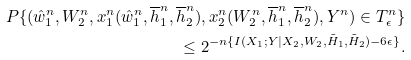<formula> <loc_0><loc_0><loc_500><loc_500>P \{ ( \hat { w } _ { 1 } ^ { n } , W _ { 2 } ^ { n } , x _ { 1 } ^ { n } ( \hat { w } _ { 1 } ^ { n } , \overline { h } _ { 1 } ^ { n } , \overline { h } _ { 2 } ^ { n } ) , x _ { 2 } ^ { n } ( W _ { 2 } ^ { n } , \overline { h } _ { 1 } ^ { n } , \overline { h } _ { 2 } ^ { n } ) , Y ^ { n } ) \in T _ { \epsilon } ^ { n } \} \\ \leq 2 ^ { - n \{ I ( X _ { 1 } ; Y | X _ { 2 } , W _ { 2 } , \tilde { H } _ { 1 } , \tilde { H } _ { 2 } ) - 6 \epsilon \} } .</formula> 